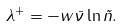Convert formula to latex. <formula><loc_0><loc_0><loc_500><loc_500>\lambda ^ { + } = - w \bar { \nu } \ln \tilde { n } .</formula> 